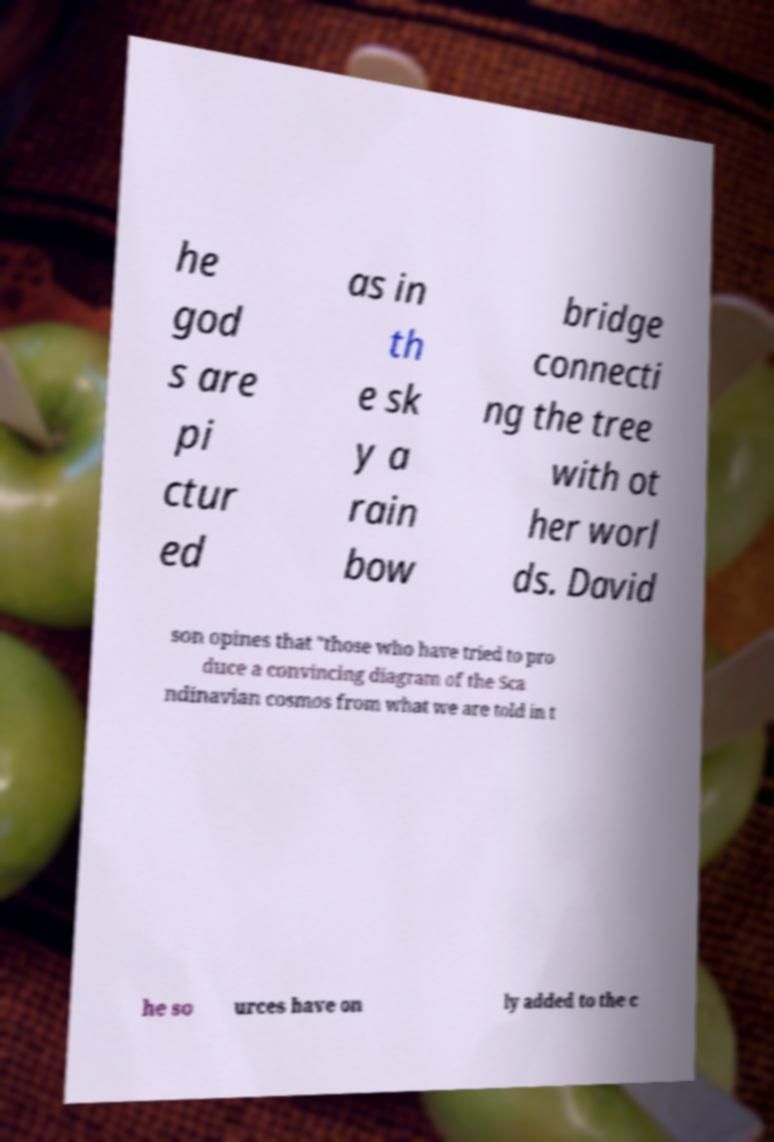Can you accurately transcribe the text from the provided image for me? he god s are pi ctur ed as in th e sk y a rain bow bridge connecti ng the tree with ot her worl ds. David son opines that "those who have tried to pro duce a convincing diagram of the Sca ndinavian cosmos from what we are told in t he so urces have on ly added to the c 